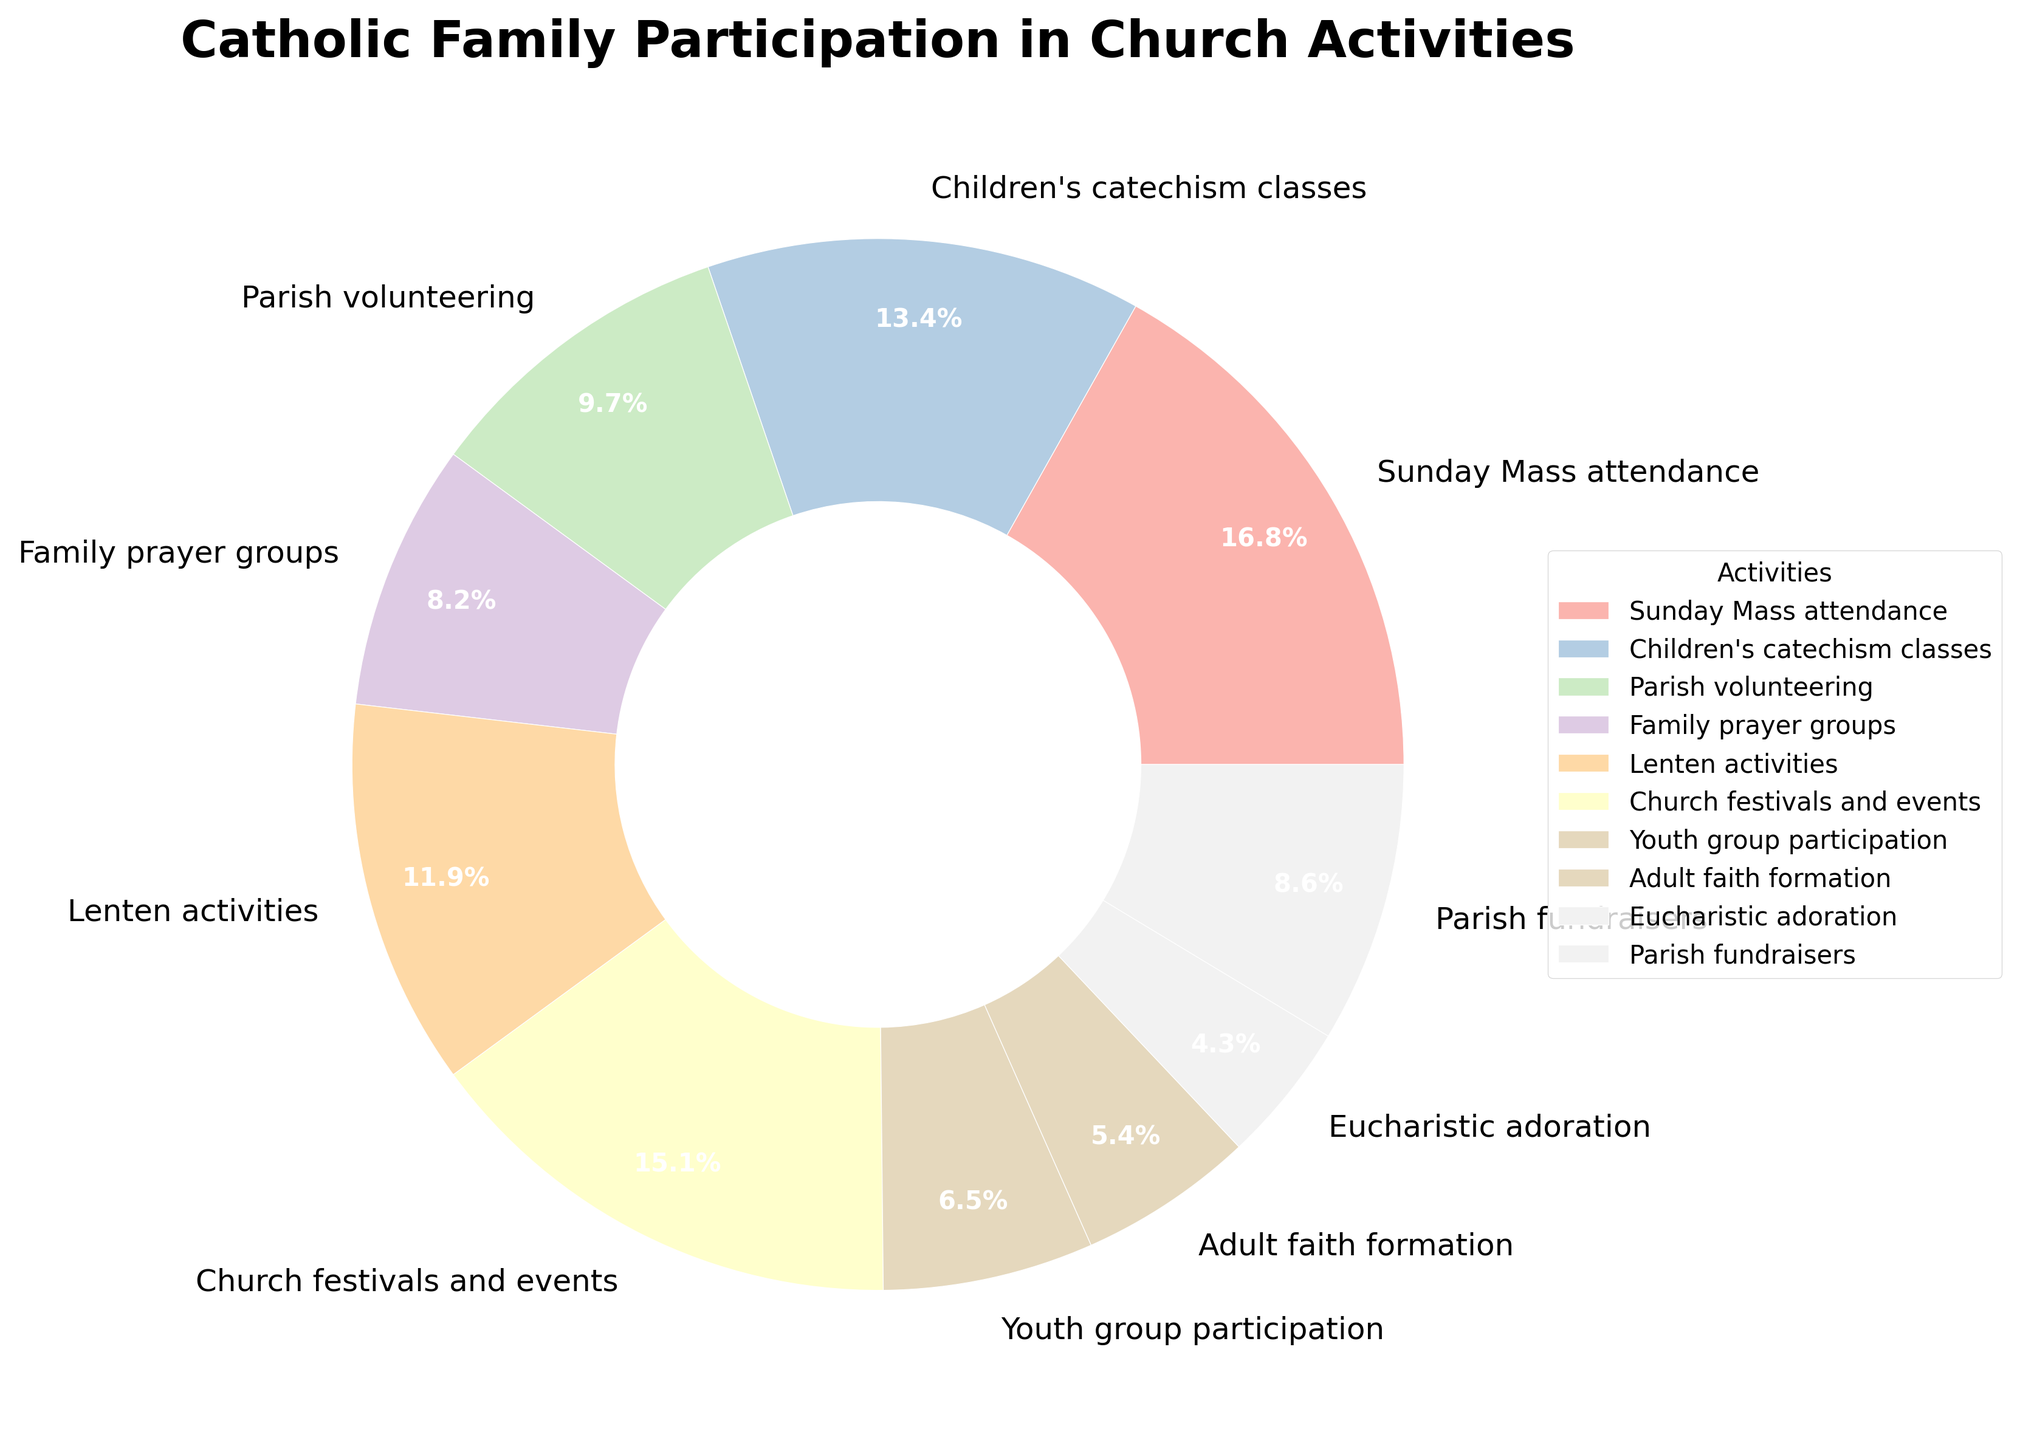Which activity has the highest percentage of participation? The activity with the highest percentage of participation is identified visually by finding the largest segment in the pie chart.
Answer: Sunday Mass attendance Which activity has the lowest percentage of participation? The activity with the lowest percentage of participation is identified visually by finding the smallest segment in the pie chart.
Answer: Eucharistic adoration Is participating in Parish volunteering more common than in Family prayer groups? Compare the sizes of the slices for Parish volunteering and Family prayer groups. Parish volunteering is visually represented by a larger slice than Family prayer groups.
Answer: Yes What is the combined percentage of families participating in Youth group participation and Adult faith formation? To find the combined percentage, add the two individual percentages from the chart: Youth group participation (30%) and Adult faith formation (25%).
Answer: 55% Which is more popular: Church festivals and events or Parish fundraisers? Compare the sizes of the slices for Church festivals and events and Parish fundraisers. Church festivals and events have a larger slice than Parish fundraisers.
Answer: Church festivals and events Calculate the average percentage of participation across all listed activities. Sum all the percentages and divide by the number of activities (10). The sum is 78 + 62 + 45 + 38 + 55 + 70 + 30 + 25 + 20 + 40 = 463. The average is 463 / 10.
Answer: 46.3% Are there more families participating in Lenten activities or in Children's catechism classes? Compare the sizes of the slices for Lenten activities and Children's catechism classes. Children's catechism classes have a larger slice than Lenten activities.
Answer: Children's catechism classes How much larger is the percentage of families attending Sunday Mass compared to Youth group participation? Subtract the percentage of Youth group participation (30%) from Sunday Mass attendance (78%). The difference is 78 - 30.
Answer: 48% Is the percentage of families involved in Parish fundraisers closer to the percentage for Parish volunteering or Family prayer groups? Compare the differences between Parish fundraisers (40%) and both Parish volunteering (45%) and Family prayer groups (38%). The difference between Parish fundraisers and Parish volunteering is 5% (45 - 40). The difference between Parish fundraisers and Family prayer groups is 2% (40 - 38).
Answer: Family prayer groups Among Family prayer groups, Parish fundraisers, and Parish volunteering, which has the largest percentage? Compare the sizes of the slices for Family prayer groups (38%), Parish fundraisers (40%), and Parish volunteering (45%). Parish volunteering has the largest percentage.
Answer: Parish volunteering 